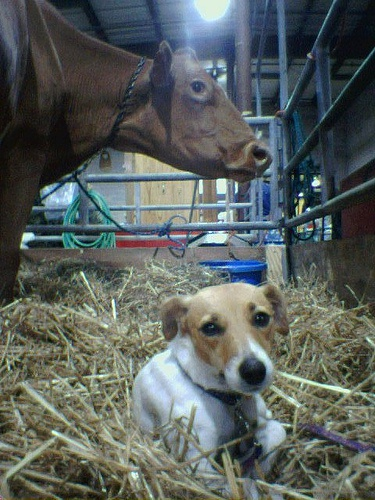Describe the objects in this image and their specific colors. I can see cow in gray and black tones and dog in gray, darkgray, black, and lightblue tones in this image. 